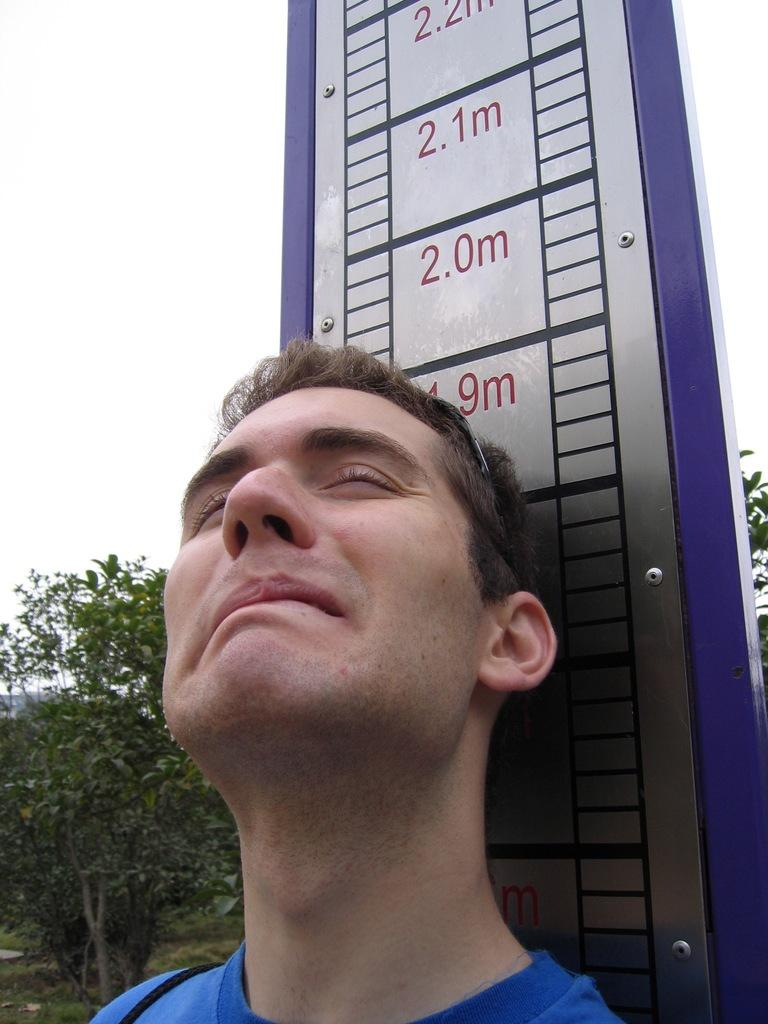What is the person in the image doing near the measuring scale? The person is standing near a measuring scale in the image. What type of natural environment can be seen in the image? There are trees visible in the image. What is visible in the background of the image? The sky is visible in the image. What type of throne is the person sitting on in the image? There is no throne present in the image; the person is standing near a measuring scale. How many sticks are being used by the person in the image? There are no sticks visible in the image. 